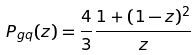Convert formula to latex. <formula><loc_0><loc_0><loc_500><loc_500>P _ { g q } ( z ) = \frac { 4 } { 3 } \frac { 1 + ( 1 - z ) ^ { 2 } } { z }</formula> 